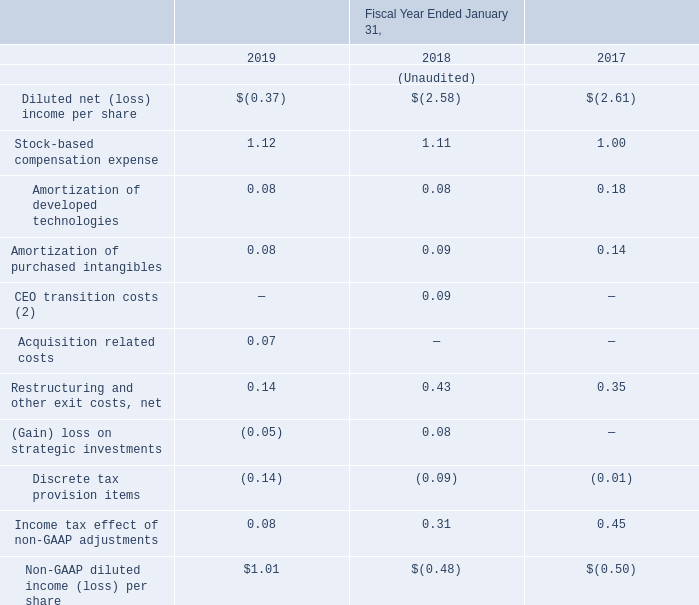(1) Totals may not sum due to rounding.
(2) CEO transition costs include stock-based compensation of $16.4 million related to the acceleration of eligible stock awards in conjunction with the Company's former CEOs' transition agreements for the fiscal year ended January 31, 2018.
Our non-GAAP financial measures may exclude the following:
Stock-based compensation expenses. We exclude stock-based compensation expenses from non-GAAP measures primarily because they are non-cash expenses and management finds it useful to exclude certain non-cash charges to assess the appropriate level of various operating expenses to assist in budgeting, planning and forecasting future periods. Moreover, because of varying available valuation methodologies, subjective assumptions and the variety of award types that companies can use under FASB ASC Topic 718, we believe excluding stock-based compensation expenses allows investors to make meaningful comparisons between our recurring core business operating results and those of other companies.
Amortization of developed technologies and purchased intangibles. We incur amortization of acquisition-related developed technology and purchased intangibles in connection with acquisitions of certain businesses and technologies. Amortization of developed technologies and purchased intangibles is inconsistent in amount and frequency and is significantly affected by the timing and size of our acquisitions. Management finds it useful to exclude these variable charges from our cost of revenues to assist in budgeting, planning and forecasting future periods. Investors should note that the use of intangible assets contributed to our revenues earned during the periods presented and will contribute to our future period revenues as well. Amortization of developed technologies and purchased intangible assets will recur in future periods.
CEO transition costs. We exclude amounts paid to the Company's former CEOs upon departure under the terms of their transition agreements, including severance payments, acceleration of restricted stock units, and continued vesting of performance stock units, and legal fees incurred with the transition. Also excluded from our non-GAAP measures are recruiting costs related to the search for a new CEO. These costs represent non-recurring expenses and are not indicative of our ongoing operating expenses. We further believe that excluding the CEO transition costs from our non-GAAP results is useful to investors in that it allows for period-over-period comparability
Goodwill impairment. This is a non-cash charge to write-down goodwill to fair value when there was an indication that the asset was impaired. As explained above, management finds it useful to exclude certain non-cash charges to assess the appropriate level of various operating expenses to assist in budgeting, planning and forecasting future periods
Restructuring and other exit costs, net. These expenses are associated with realigning our business strategies based on current economic conditions. In connection with these restructuring actions or other exit actions, we recognize costs related to termination benefits for former employees whose positions were eliminated, the closure of facilities and cancellation of certain contracts. We exclude these charges because these expenses are not reflective of ongoing business and operating results. We believe it is useful for investors to understand the effects of these items on our total operating expenses.
Acquisition related costs. We exclude certain acquisition related costs, including due diligence costs, professional fees in connection with an acquisition, certain financing costs, and certain integration related expenses. These expenses are unpredictable, and dependent on factors that may be outside of our control and unrelated to the continuing operations of the acquired business, or our Company. In addition, the size and complexity of an acquisition, which often drives the magnitude of acquisition related costs, may not be indicative of such future costs. We believe excluding acquisition related costs facilitates the comparison of our financial results to the Company's historical operating results and to other companies in our industry.
(Gain) loss on strategic investments and dispositions. We exclude gains and losses related to our strategic investments and dispositions from our non-GAAP measures primarily because management finds it useful to exclude these variable gains and losses on these investments and dispositions in assessing our financial results. Included in these amounts are non-cash unrealized gains and losses on the derivative components, dividends received, realized gains and losses on the sales or losses on the impairment of these investments and dispositions. We believe excluding these items is useful to investors because these excluded items do not correlate to the underlying performance of our business and these losses or gains were incurred in connection with strategic investments and dispositions which do not occur regularly.
Discrete tax items. We exclude the GAAP tax provision, including discrete items, from the non-GAAP measure of net (loss) income, and include a non-GAAP tax provision based upon the projected annual non-GAAP effective tax rate. Discrete tax items include income tax expenses or benefits that do not relate to ordinary income from continuing operations in the current fiscal year, unusual or infrequently occurring items, or the tax impact of certain stock-based compensation. Examples of discrete tax items include, but are not limited to, certain changes in judgment and changes in estimates of tax matters related to prior fiscal years, certain costs related to business combinations, certain changes in the realizability of deferred tax assets or changes in tax law. Management believes this approach assists investors in understanding the tax provision and the effective tax rate related to ongoing operations. We believe the exclusion of these discrete tax items provides investors with useful supplemental information about our operational performance.
Establishment of a valuation allowance on certain net deferred tax assets. This is a non-cash charge to record a valuation allowance on certain deferred tax assets. As explained above, management finds it useful to exclude certain non-cash charges to assess the appropriate level of various cash expenses to assist in budgeting, planning and forecasting future periods
Income tax effects on the difference between GAAP and non-GAAP costs and expenses. The income tax effects that are excluded from the non-GAAP measures relate to the tax impact on the difference between GAAP and non-GAAP expenses, primarily due to stock-based compensation, amortization of purchased intangibles and restructuring charges and other exit costs (benefits) for GAAP and non-GAAP measures.
What is the average net restructing and exit costs over the 3 year period? (0.14+0.43+0.35)/3 
Answer: 0.31. Why does the company exclude stock-based compensation expenses? We exclude stock-based compensation expenses from non-gaap measures primarily because they are non-cash expenses and management finds it useful to exclude certain non-cash charges to assess the appropriate level of various operating expenses to assist in budgeting, planning and forecasting future periods. Why does the company exclude acquisition costs? We believe excluding acquisition related costs facilitates the comparison of our financial results to the company's historical operating results and to other companies in our industry. How much was the stock-based compensation for the former CEOs' transition agreements? $16.4 million. What is the difference between the non-GAAP diluted income per share and the diluted net  (loss) income per share in 2019? 1.01-(-0.37) 
Answer: 1.38. What was the average stock-based compensation expense over the last 3 years? (1.12+1.11+1)/3 
Answer: 1.08. 